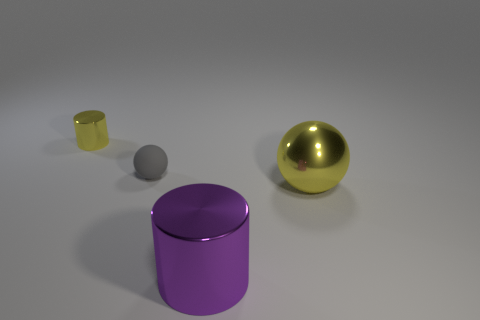Add 3 brown spheres. How many objects exist? 7 Add 2 small gray matte things. How many small gray matte things exist? 3 Subtract 1 yellow cylinders. How many objects are left? 3 Subtract all big yellow matte balls. Subtract all cylinders. How many objects are left? 2 Add 2 tiny gray objects. How many tiny gray objects are left? 3 